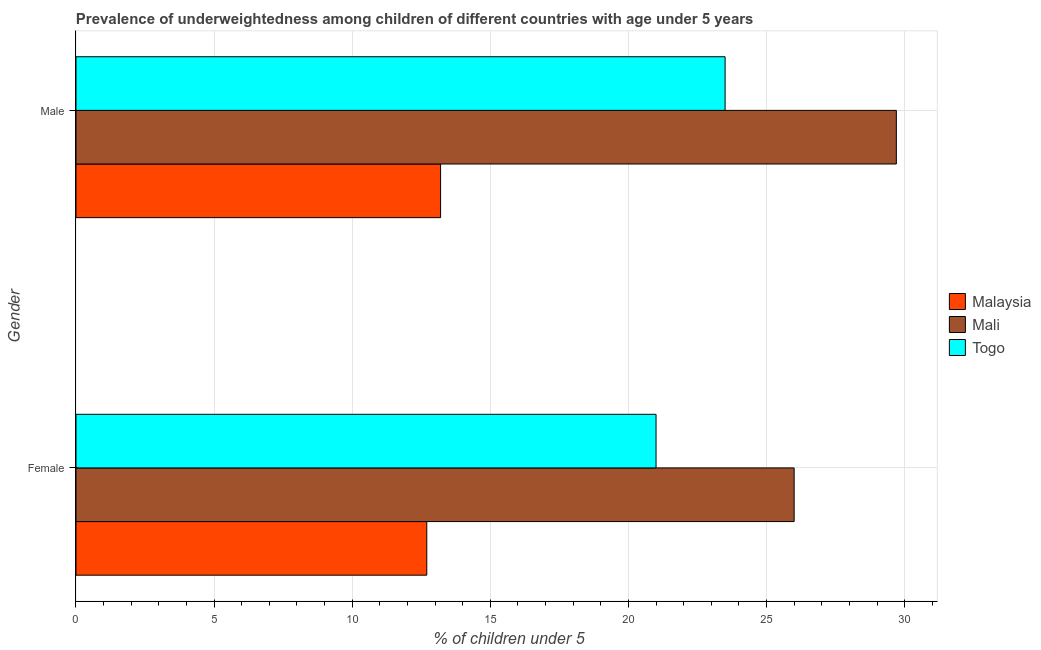How many groups of bars are there?
Provide a succinct answer. 2. Are the number of bars per tick equal to the number of legend labels?
Keep it short and to the point. Yes. How many bars are there on the 2nd tick from the bottom?
Keep it short and to the point. 3. What is the percentage of underweighted female children in Malaysia?
Offer a very short reply. 12.7. Across all countries, what is the minimum percentage of underweighted male children?
Your response must be concise. 13.2. In which country was the percentage of underweighted female children maximum?
Give a very brief answer. Mali. In which country was the percentage of underweighted female children minimum?
Your response must be concise. Malaysia. What is the total percentage of underweighted male children in the graph?
Give a very brief answer. 66.4. What is the difference between the percentage of underweighted female children in Malaysia and the percentage of underweighted male children in Mali?
Give a very brief answer. -17. What is the average percentage of underweighted female children per country?
Your answer should be very brief. 19.9. What is the difference between the percentage of underweighted female children and percentage of underweighted male children in Mali?
Make the answer very short. -3.7. What is the ratio of the percentage of underweighted female children in Togo to that in Malaysia?
Make the answer very short. 1.65. What does the 2nd bar from the top in Male represents?
Offer a very short reply. Mali. What does the 1st bar from the bottom in Male represents?
Your answer should be very brief. Malaysia. How many bars are there?
Your answer should be very brief. 6. Are all the bars in the graph horizontal?
Provide a succinct answer. Yes. What is the difference between two consecutive major ticks on the X-axis?
Ensure brevity in your answer.  5. Are the values on the major ticks of X-axis written in scientific E-notation?
Give a very brief answer. No. Does the graph contain any zero values?
Your response must be concise. No. Where does the legend appear in the graph?
Your answer should be compact. Center right. How many legend labels are there?
Give a very brief answer. 3. How are the legend labels stacked?
Keep it short and to the point. Vertical. What is the title of the graph?
Make the answer very short. Prevalence of underweightedness among children of different countries with age under 5 years. Does "Rwanda" appear as one of the legend labels in the graph?
Provide a succinct answer. No. What is the label or title of the X-axis?
Offer a terse response.  % of children under 5. What is the label or title of the Y-axis?
Your answer should be very brief. Gender. What is the  % of children under 5 of Malaysia in Female?
Your response must be concise. 12.7. What is the  % of children under 5 of Mali in Female?
Your answer should be very brief. 26. What is the  % of children under 5 of Malaysia in Male?
Ensure brevity in your answer.  13.2. What is the  % of children under 5 of Mali in Male?
Keep it short and to the point. 29.7. What is the  % of children under 5 of Togo in Male?
Your answer should be compact. 23.5. Across all Gender, what is the maximum  % of children under 5 of Malaysia?
Offer a very short reply. 13.2. Across all Gender, what is the maximum  % of children under 5 in Mali?
Your answer should be compact. 29.7. Across all Gender, what is the minimum  % of children under 5 in Malaysia?
Provide a short and direct response. 12.7. Across all Gender, what is the minimum  % of children under 5 in Mali?
Your answer should be compact. 26. What is the total  % of children under 5 of Malaysia in the graph?
Provide a succinct answer. 25.9. What is the total  % of children under 5 of Mali in the graph?
Provide a short and direct response. 55.7. What is the total  % of children under 5 in Togo in the graph?
Offer a terse response. 44.5. What is the difference between the  % of children under 5 in Mali in Female and that in Male?
Keep it short and to the point. -3.7. What is the difference between the  % of children under 5 in Togo in Female and that in Male?
Give a very brief answer. -2.5. What is the difference between the  % of children under 5 of Malaysia in Female and the  % of children under 5 of Togo in Male?
Offer a terse response. -10.8. What is the average  % of children under 5 of Malaysia per Gender?
Offer a terse response. 12.95. What is the average  % of children under 5 of Mali per Gender?
Your answer should be compact. 27.85. What is the average  % of children under 5 of Togo per Gender?
Ensure brevity in your answer.  22.25. What is the difference between the  % of children under 5 of Malaysia and  % of children under 5 of Mali in Female?
Your answer should be very brief. -13.3. What is the difference between the  % of children under 5 in Mali and  % of children under 5 in Togo in Female?
Offer a terse response. 5. What is the difference between the  % of children under 5 of Malaysia and  % of children under 5 of Mali in Male?
Offer a terse response. -16.5. What is the ratio of the  % of children under 5 of Malaysia in Female to that in Male?
Offer a very short reply. 0.96. What is the ratio of the  % of children under 5 of Mali in Female to that in Male?
Provide a short and direct response. 0.88. What is the ratio of the  % of children under 5 in Togo in Female to that in Male?
Your response must be concise. 0.89. What is the difference between the highest and the second highest  % of children under 5 in Malaysia?
Provide a short and direct response. 0.5. What is the difference between the highest and the second highest  % of children under 5 in Mali?
Provide a succinct answer. 3.7. What is the difference between the highest and the lowest  % of children under 5 in Malaysia?
Keep it short and to the point. 0.5. What is the difference between the highest and the lowest  % of children under 5 in Mali?
Offer a very short reply. 3.7. 